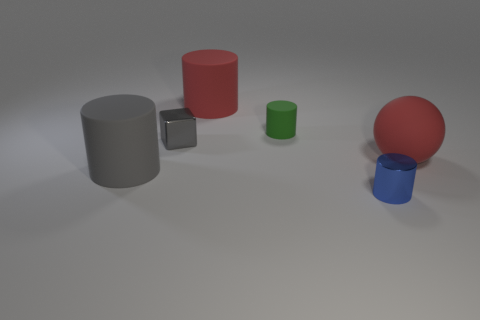Subtract 1 cylinders. How many cylinders are left? 3 Add 1 cyan matte things. How many objects exist? 7 Subtract all spheres. How many objects are left? 5 Add 3 tiny metallic cylinders. How many tiny metallic cylinders are left? 4 Add 3 large brown matte things. How many large brown matte things exist? 3 Subtract 0 blue spheres. How many objects are left? 6 Subtract all big balls. Subtract all large rubber balls. How many objects are left? 4 